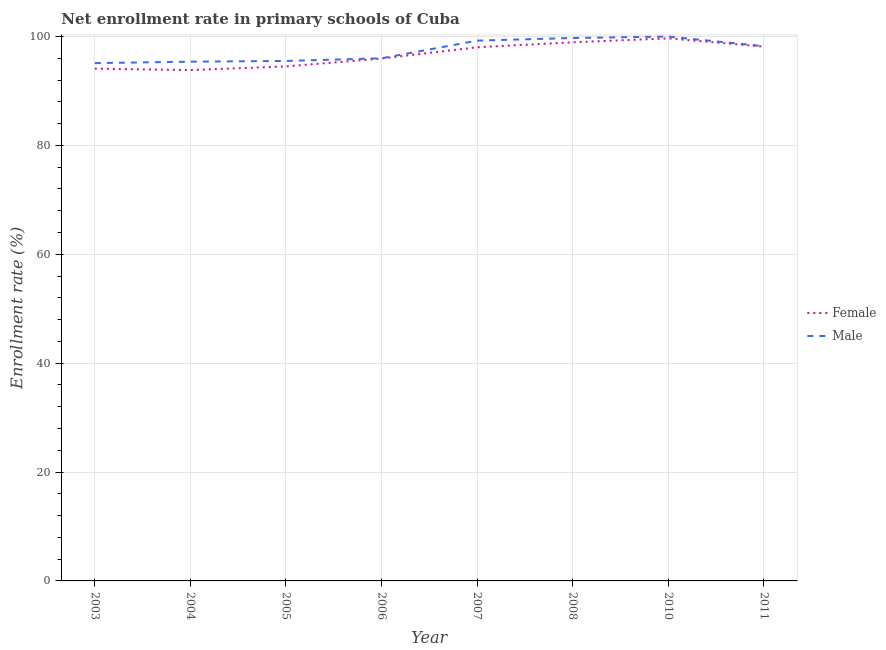Is the number of lines equal to the number of legend labels?
Provide a succinct answer. Yes. What is the enrollment rate of female students in 2011?
Offer a terse response. 98.14. Across all years, what is the maximum enrollment rate of male students?
Provide a succinct answer. 100. Across all years, what is the minimum enrollment rate of male students?
Your response must be concise. 95.12. In which year was the enrollment rate of female students maximum?
Your answer should be compact. 2010. What is the total enrollment rate of male students in the graph?
Make the answer very short. 779.22. What is the difference between the enrollment rate of female students in 2003 and that in 2004?
Offer a very short reply. 0.26. What is the difference between the enrollment rate of female students in 2006 and the enrollment rate of male students in 2007?
Your response must be concise. -3.29. What is the average enrollment rate of female students per year?
Make the answer very short. 96.65. In the year 2006, what is the difference between the enrollment rate of female students and enrollment rate of male students?
Offer a very short reply. -0.05. In how many years, is the enrollment rate of male students greater than 68 %?
Give a very brief answer. 8. What is the ratio of the enrollment rate of female students in 2005 to that in 2011?
Your answer should be compact. 0.96. Is the enrollment rate of male students in 2005 less than that in 2006?
Give a very brief answer. Yes. What is the difference between the highest and the second highest enrollment rate of female students?
Your answer should be compact. 0.72. What is the difference between the highest and the lowest enrollment rate of female students?
Make the answer very short. 5.83. In how many years, is the enrollment rate of male students greater than the average enrollment rate of male students taken over all years?
Offer a very short reply. 4. Is the enrollment rate of female students strictly less than the enrollment rate of male students over the years?
Your answer should be compact. Yes. How many lines are there?
Provide a short and direct response. 2. How many years are there in the graph?
Offer a terse response. 8. Are the values on the major ticks of Y-axis written in scientific E-notation?
Provide a short and direct response. No. Does the graph contain grids?
Ensure brevity in your answer.  Yes. How are the legend labels stacked?
Ensure brevity in your answer.  Vertical. What is the title of the graph?
Your answer should be very brief. Net enrollment rate in primary schools of Cuba. What is the label or title of the X-axis?
Keep it short and to the point. Year. What is the label or title of the Y-axis?
Provide a short and direct response. Enrollment rate (%). What is the Enrollment rate (%) of Female in 2003?
Give a very brief answer. 94.1. What is the Enrollment rate (%) in Male in 2003?
Your answer should be compact. 95.12. What is the Enrollment rate (%) in Female in 2004?
Offer a very short reply. 93.84. What is the Enrollment rate (%) of Male in 2004?
Keep it short and to the point. 95.38. What is the Enrollment rate (%) in Female in 2005?
Offer a very short reply. 94.51. What is the Enrollment rate (%) of Male in 2005?
Offer a very short reply. 95.52. What is the Enrollment rate (%) in Female in 2006?
Your answer should be compact. 95.96. What is the Enrollment rate (%) in Male in 2006?
Offer a very short reply. 96.01. What is the Enrollment rate (%) of Female in 2007?
Ensure brevity in your answer.  98.03. What is the Enrollment rate (%) of Male in 2007?
Give a very brief answer. 99.25. What is the Enrollment rate (%) of Female in 2008?
Offer a very short reply. 98.94. What is the Enrollment rate (%) of Male in 2008?
Give a very brief answer. 99.73. What is the Enrollment rate (%) of Female in 2010?
Ensure brevity in your answer.  99.66. What is the Enrollment rate (%) of Male in 2010?
Provide a succinct answer. 100. What is the Enrollment rate (%) of Female in 2011?
Ensure brevity in your answer.  98.14. What is the Enrollment rate (%) in Male in 2011?
Ensure brevity in your answer.  98.22. Across all years, what is the maximum Enrollment rate (%) of Female?
Your answer should be very brief. 99.66. Across all years, what is the maximum Enrollment rate (%) in Male?
Offer a very short reply. 100. Across all years, what is the minimum Enrollment rate (%) in Female?
Provide a succinct answer. 93.84. Across all years, what is the minimum Enrollment rate (%) of Male?
Give a very brief answer. 95.12. What is the total Enrollment rate (%) of Female in the graph?
Your answer should be compact. 773.19. What is the total Enrollment rate (%) in Male in the graph?
Your answer should be compact. 779.22. What is the difference between the Enrollment rate (%) of Female in 2003 and that in 2004?
Offer a terse response. 0.26. What is the difference between the Enrollment rate (%) in Male in 2003 and that in 2004?
Your answer should be compact. -0.26. What is the difference between the Enrollment rate (%) in Female in 2003 and that in 2005?
Ensure brevity in your answer.  -0.41. What is the difference between the Enrollment rate (%) of Male in 2003 and that in 2005?
Your answer should be very brief. -0.4. What is the difference between the Enrollment rate (%) in Female in 2003 and that in 2006?
Offer a terse response. -1.86. What is the difference between the Enrollment rate (%) of Male in 2003 and that in 2006?
Offer a terse response. -0.89. What is the difference between the Enrollment rate (%) in Female in 2003 and that in 2007?
Make the answer very short. -3.93. What is the difference between the Enrollment rate (%) in Male in 2003 and that in 2007?
Your answer should be compact. -4.13. What is the difference between the Enrollment rate (%) of Female in 2003 and that in 2008?
Give a very brief answer. -4.84. What is the difference between the Enrollment rate (%) in Male in 2003 and that in 2008?
Offer a terse response. -4.61. What is the difference between the Enrollment rate (%) in Female in 2003 and that in 2010?
Provide a short and direct response. -5.56. What is the difference between the Enrollment rate (%) of Male in 2003 and that in 2010?
Offer a very short reply. -4.88. What is the difference between the Enrollment rate (%) in Female in 2003 and that in 2011?
Your response must be concise. -4.04. What is the difference between the Enrollment rate (%) in Male in 2003 and that in 2011?
Offer a very short reply. -3.1. What is the difference between the Enrollment rate (%) of Female in 2004 and that in 2005?
Provide a short and direct response. -0.68. What is the difference between the Enrollment rate (%) of Male in 2004 and that in 2005?
Keep it short and to the point. -0.14. What is the difference between the Enrollment rate (%) in Female in 2004 and that in 2006?
Your answer should be very brief. -2.12. What is the difference between the Enrollment rate (%) of Male in 2004 and that in 2006?
Ensure brevity in your answer.  -0.62. What is the difference between the Enrollment rate (%) of Female in 2004 and that in 2007?
Make the answer very short. -4.19. What is the difference between the Enrollment rate (%) of Male in 2004 and that in 2007?
Your answer should be compact. -3.87. What is the difference between the Enrollment rate (%) in Female in 2004 and that in 2008?
Offer a very short reply. -5.1. What is the difference between the Enrollment rate (%) of Male in 2004 and that in 2008?
Your answer should be compact. -4.35. What is the difference between the Enrollment rate (%) of Female in 2004 and that in 2010?
Your answer should be compact. -5.83. What is the difference between the Enrollment rate (%) of Male in 2004 and that in 2010?
Your response must be concise. -4.62. What is the difference between the Enrollment rate (%) of Female in 2004 and that in 2011?
Your response must be concise. -4.31. What is the difference between the Enrollment rate (%) in Male in 2004 and that in 2011?
Provide a succinct answer. -2.84. What is the difference between the Enrollment rate (%) in Female in 2005 and that in 2006?
Make the answer very short. -1.45. What is the difference between the Enrollment rate (%) in Male in 2005 and that in 2006?
Provide a short and direct response. -0.49. What is the difference between the Enrollment rate (%) in Female in 2005 and that in 2007?
Your response must be concise. -3.51. What is the difference between the Enrollment rate (%) in Male in 2005 and that in 2007?
Make the answer very short. -3.73. What is the difference between the Enrollment rate (%) of Female in 2005 and that in 2008?
Give a very brief answer. -4.43. What is the difference between the Enrollment rate (%) of Male in 2005 and that in 2008?
Offer a very short reply. -4.21. What is the difference between the Enrollment rate (%) of Female in 2005 and that in 2010?
Your response must be concise. -5.15. What is the difference between the Enrollment rate (%) in Male in 2005 and that in 2010?
Offer a very short reply. -4.48. What is the difference between the Enrollment rate (%) in Female in 2005 and that in 2011?
Make the answer very short. -3.63. What is the difference between the Enrollment rate (%) of Male in 2005 and that in 2011?
Provide a succinct answer. -2.71. What is the difference between the Enrollment rate (%) of Female in 2006 and that in 2007?
Provide a succinct answer. -2.07. What is the difference between the Enrollment rate (%) in Male in 2006 and that in 2007?
Offer a terse response. -3.24. What is the difference between the Enrollment rate (%) in Female in 2006 and that in 2008?
Give a very brief answer. -2.98. What is the difference between the Enrollment rate (%) of Male in 2006 and that in 2008?
Offer a terse response. -3.72. What is the difference between the Enrollment rate (%) of Female in 2006 and that in 2010?
Your answer should be very brief. -3.7. What is the difference between the Enrollment rate (%) in Male in 2006 and that in 2010?
Provide a short and direct response. -3.99. What is the difference between the Enrollment rate (%) of Female in 2006 and that in 2011?
Offer a terse response. -2.19. What is the difference between the Enrollment rate (%) in Male in 2006 and that in 2011?
Make the answer very short. -2.22. What is the difference between the Enrollment rate (%) of Female in 2007 and that in 2008?
Provide a succinct answer. -0.91. What is the difference between the Enrollment rate (%) in Male in 2007 and that in 2008?
Your answer should be compact. -0.48. What is the difference between the Enrollment rate (%) in Female in 2007 and that in 2010?
Make the answer very short. -1.64. What is the difference between the Enrollment rate (%) of Male in 2007 and that in 2010?
Give a very brief answer. -0.75. What is the difference between the Enrollment rate (%) in Female in 2007 and that in 2011?
Provide a succinct answer. -0.12. What is the difference between the Enrollment rate (%) in Male in 2007 and that in 2011?
Your answer should be compact. 1.03. What is the difference between the Enrollment rate (%) of Female in 2008 and that in 2010?
Provide a short and direct response. -0.72. What is the difference between the Enrollment rate (%) in Male in 2008 and that in 2010?
Provide a short and direct response. -0.27. What is the difference between the Enrollment rate (%) in Female in 2008 and that in 2011?
Make the answer very short. 0.8. What is the difference between the Enrollment rate (%) of Male in 2008 and that in 2011?
Make the answer very short. 1.51. What is the difference between the Enrollment rate (%) in Female in 2010 and that in 2011?
Give a very brief answer. 1.52. What is the difference between the Enrollment rate (%) in Male in 2010 and that in 2011?
Provide a succinct answer. 1.78. What is the difference between the Enrollment rate (%) of Female in 2003 and the Enrollment rate (%) of Male in 2004?
Your response must be concise. -1.28. What is the difference between the Enrollment rate (%) in Female in 2003 and the Enrollment rate (%) in Male in 2005?
Provide a succinct answer. -1.41. What is the difference between the Enrollment rate (%) of Female in 2003 and the Enrollment rate (%) of Male in 2006?
Provide a succinct answer. -1.9. What is the difference between the Enrollment rate (%) in Female in 2003 and the Enrollment rate (%) in Male in 2007?
Your response must be concise. -5.15. What is the difference between the Enrollment rate (%) of Female in 2003 and the Enrollment rate (%) of Male in 2008?
Ensure brevity in your answer.  -5.63. What is the difference between the Enrollment rate (%) in Female in 2003 and the Enrollment rate (%) in Male in 2010?
Your answer should be compact. -5.9. What is the difference between the Enrollment rate (%) of Female in 2003 and the Enrollment rate (%) of Male in 2011?
Give a very brief answer. -4.12. What is the difference between the Enrollment rate (%) of Female in 2004 and the Enrollment rate (%) of Male in 2005?
Your answer should be very brief. -1.68. What is the difference between the Enrollment rate (%) in Female in 2004 and the Enrollment rate (%) in Male in 2006?
Make the answer very short. -2.17. What is the difference between the Enrollment rate (%) in Female in 2004 and the Enrollment rate (%) in Male in 2007?
Provide a short and direct response. -5.41. What is the difference between the Enrollment rate (%) in Female in 2004 and the Enrollment rate (%) in Male in 2008?
Give a very brief answer. -5.89. What is the difference between the Enrollment rate (%) in Female in 2004 and the Enrollment rate (%) in Male in 2010?
Provide a short and direct response. -6.16. What is the difference between the Enrollment rate (%) in Female in 2004 and the Enrollment rate (%) in Male in 2011?
Offer a very short reply. -4.38. What is the difference between the Enrollment rate (%) in Female in 2005 and the Enrollment rate (%) in Male in 2006?
Offer a very short reply. -1.49. What is the difference between the Enrollment rate (%) in Female in 2005 and the Enrollment rate (%) in Male in 2007?
Make the answer very short. -4.74. What is the difference between the Enrollment rate (%) of Female in 2005 and the Enrollment rate (%) of Male in 2008?
Offer a very short reply. -5.22. What is the difference between the Enrollment rate (%) in Female in 2005 and the Enrollment rate (%) in Male in 2010?
Keep it short and to the point. -5.48. What is the difference between the Enrollment rate (%) in Female in 2005 and the Enrollment rate (%) in Male in 2011?
Provide a succinct answer. -3.71. What is the difference between the Enrollment rate (%) in Female in 2006 and the Enrollment rate (%) in Male in 2007?
Make the answer very short. -3.29. What is the difference between the Enrollment rate (%) in Female in 2006 and the Enrollment rate (%) in Male in 2008?
Offer a very short reply. -3.77. What is the difference between the Enrollment rate (%) of Female in 2006 and the Enrollment rate (%) of Male in 2010?
Ensure brevity in your answer.  -4.04. What is the difference between the Enrollment rate (%) in Female in 2006 and the Enrollment rate (%) in Male in 2011?
Your answer should be compact. -2.26. What is the difference between the Enrollment rate (%) in Female in 2007 and the Enrollment rate (%) in Male in 2008?
Your response must be concise. -1.7. What is the difference between the Enrollment rate (%) in Female in 2007 and the Enrollment rate (%) in Male in 2010?
Your answer should be very brief. -1.97. What is the difference between the Enrollment rate (%) of Female in 2007 and the Enrollment rate (%) of Male in 2011?
Provide a succinct answer. -0.2. What is the difference between the Enrollment rate (%) of Female in 2008 and the Enrollment rate (%) of Male in 2010?
Ensure brevity in your answer.  -1.06. What is the difference between the Enrollment rate (%) of Female in 2008 and the Enrollment rate (%) of Male in 2011?
Your answer should be very brief. 0.72. What is the difference between the Enrollment rate (%) of Female in 2010 and the Enrollment rate (%) of Male in 2011?
Offer a very short reply. 1.44. What is the average Enrollment rate (%) in Female per year?
Keep it short and to the point. 96.65. What is the average Enrollment rate (%) in Male per year?
Make the answer very short. 97.4. In the year 2003, what is the difference between the Enrollment rate (%) of Female and Enrollment rate (%) of Male?
Make the answer very short. -1.02. In the year 2004, what is the difference between the Enrollment rate (%) of Female and Enrollment rate (%) of Male?
Provide a short and direct response. -1.54. In the year 2005, what is the difference between the Enrollment rate (%) in Female and Enrollment rate (%) in Male?
Offer a very short reply. -1. In the year 2006, what is the difference between the Enrollment rate (%) in Female and Enrollment rate (%) in Male?
Give a very brief answer. -0.05. In the year 2007, what is the difference between the Enrollment rate (%) in Female and Enrollment rate (%) in Male?
Provide a short and direct response. -1.22. In the year 2008, what is the difference between the Enrollment rate (%) in Female and Enrollment rate (%) in Male?
Your answer should be very brief. -0.79. In the year 2010, what is the difference between the Enrollment rate (%) in Female and Enrollment rate (%) in Male?
Provide a succinct answer. -0.33. In the year 2011, what is the difference between the Enrollment rate (%) of Female and Enrollment rate (%) of Male?
Give a very brief answer. -0.08. What is the ratio of the Enrollment rate (%) of Male in 2003 to that in 2004?
Your answer should be very brief. 1. What is the ratio of the Enrollment rate (%) in Male in 2003 to that in 2005?
Keep it short and to the point. 1. What is the ratio of the Enrollment rate (%) of Female in 2003 to that in 2006?
Offer a very short reply. 0.98. What is the ratio of the Enrollment rate (%) of Female in 2003 to that in 2007?
Your response must be concise. 0.96. What is the ratio of the Enrollment rate (%) in Male in 2003 to that in 2007?
Keep it short and to the point. 0.96. What is the ratio of the Enrollment rate (%) of Female in 2003 to that in 2008?
Provide a short and direct response. 0.95. What is the ratio of the Enrollment rate (%) of Male in 2003 to that in 2008?
Provide a succinct answer. 0.95. What is the ratio of the Enrollment rate (%) in Female in 2003 to that in 2010?
Your answer should be very brief. 0.94. What is the ratio of the Enrollment rate (%) of Male in 2003 to that in 2010?
Provide a short and direct response. 0.95. What is the ratio of the Enrollment rate (%) in Female in 2003 to that in 2011?
Your answer should be very brief. 0.96. What is the ratio of the Enrollment rate (%) of Male in 2003 to that in 2011?
Your answer should be very brief. 0.97. What is the ratio of the Enrollment rate (%) of Female in 2004 to that in 2005?
Ensure brevity in your answer.  0.99. What is the ratio of the Enrollment rate (%) of Female in 2004 to that in 2006?
Give a very brief answer. 0.98. What is the ratio of the Enrollment rate (%) of Female in 2004 to that in 2007?
Provide a succinct answer. 0.96. What is the ratio of the Enrollment rate (%) in Male in 2004 to that in 2007?
Offer a terse response. 0.96. What is the ratio of the Enrollment rate (%) in Female in 2004 to that in 2008?
Offer a very short reply. 0.95. What is the ratio of the Enrollment rate (%) of Male in 2004 to that in 2008?
Ensure brevity in your answer.  0.96. What is the ratio of the Enrollment rate (%) of Female in 2004 to that in 2010?
Your answer should be very brief. 0.94. What is the ratio of the Enrollment rate (%) of Male in 2004 to that in 2010?
Provide a short and direct response. 0.95. What is the ratio of the Enrollment rate (%) of Female in 2004 to that in 2011?
Provide a succinct answer. 0.96. What is the ratio of the Enrollment rate (%) of Male in 2004 to that in 2011?
Make the answer very short. 0.97. What is the ratio of the Enrollment rate (%) in Female in 2005 to that in 2006?
Keep it short and to the point. 0.98. What is the ratio of the Enrollment rate (%) in Male in 2005 to that in 2006?
Your answer should be compact. 0.99. What is the ratio of the Enrollment rate (%) of Female in 2005 to that in 2007?
Give a very brief answer. 0.96. What is the ratio of the Enrollment rate (%) in Male in 2005 to that in 2007?
Provide a short and direct response. 0.96. What is the ratio of the Enrollment rate (%) in Female in 2005 to that in 2008?
Provide a succinct answer. 0.96. What is the ratio of the Enrollment rate (%) of Male in 2005 to that in 2008?
Provide a short and direct response. 0.96. What is the ratio of the Enrollment rate (%) of Female in 2005 to that in 2010?
Ensure brevity in your answer.  0.95. What is the ratio of the Enrollment rate (%) in Male in 2005 to that in 2010?
Provide a short and direct response. 0.96. What is the ratio of the Enrollment rate (%) of Male in 2005 to that in 2011?
Offer a very short reply. 0.97. What is the ratio of the Enrollment rate (%) in Female in 2006 to that in 2007?
Keep it short and to the point. 0.98. What is the ratio of the Enrollment rate (%) in Male in 2006 to that in 2007?
Your answer should be compact. 0.97. What is the ratio of the Enrollment rate (%) in Female in 2006 to that in 2008?
Your answer should be compact. 0.97. What is the ratio of the Enrollment rate (%) of Male in 2006 to that in 2008?
Offer a terse response. 0.96. What is the ratio of the Enrollment rate (%) of Female in 2006 to that in 2010?
Your answer should be compact. 0.96. What is the ratio of the Enrollment rate (%) in Male in 2006 to that in 2010?
Provide a short and direct response. 0.96. What is the ratio of the Enrollment rate (%) of Female in 2006 to that in 2011?
Your answer should be compact. 0.98. What is the ratio of the Enrollment rate (%) in Male in 2006 to that in 2011?
Ensure brevity in your answer.  0.98. What is the ratio of the Enrollment rate (%) of Female in 2007 to that in 2008?
Make the answer very short. 0.99. What is the ratio of the Enrollment rate (%) in Male in 2007 to that in 2008?
Provide a succinct answer. 1. What is the ratio of the Enrollment rate (%) of Female in 2007 to that in 2010?
Your response must be concise. 0.98. What is the ratio of the Enrollment rate (%) in Male in 2007 to that in 2011?
Your answer should be compact. 1.01. What is the ratio of the Enrollment rate (%) of Female in 2008 to that in 2010?
Give a very brief answer. 0.99. What is the ratio of the Enrollment rate (%) in Male in 2008 to that in 2011?
Offer a very short reply. 1.02. What is the ratio of the Enrollment rate (%) in Female in 2010 to that in 2011?
Provide a short and direct response. 1.02. What is the ratio of the Enrollment rate (%) in Male in 2010 to that in 2011?
Your answer should be very brief. 1.02. What is the difference between the highest and the second highest Enrollment rate (%) in Female?
Make the answer very short. 0.72. What is the difference between the highest and the second highest Enrollment rate (%) in Male?
Your answer should be compact. 0.27. What is the difference between the highest and the lowest Enrollment rate (%) of Female?
Keep it short and to the point. 5.83. What is the difference between the highest and the lowest Enrollment rate (%) in Male?
Ensure brevity in your answer.  4.88. 